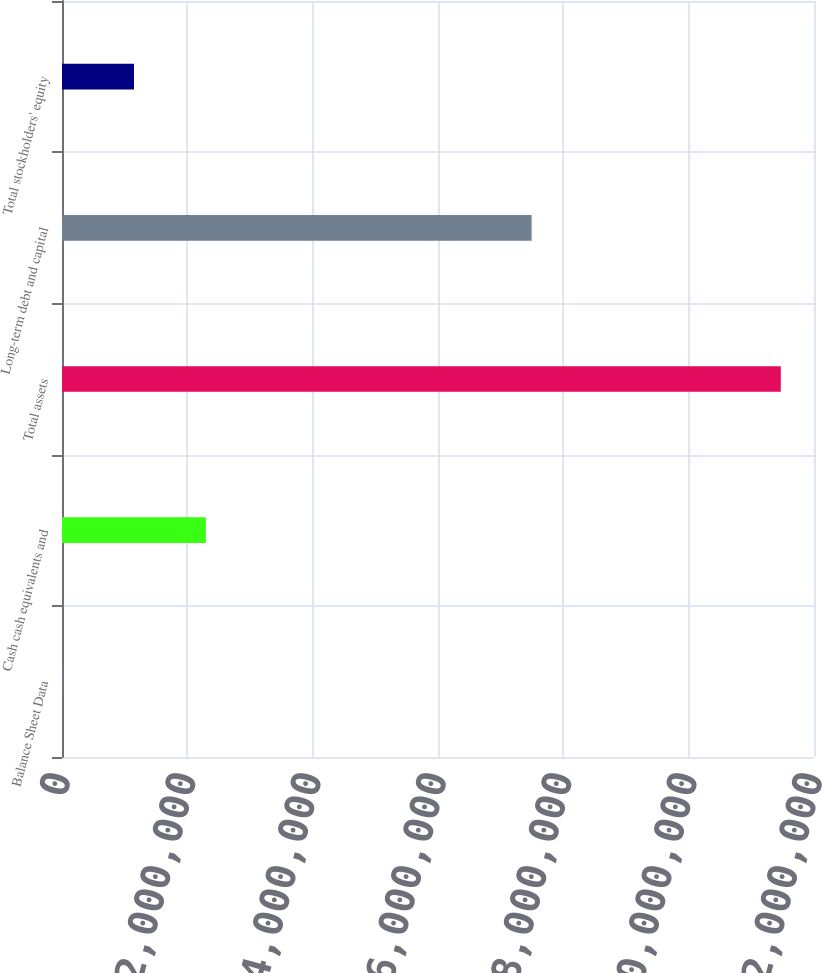<chart> <loc_0><loc_0><loc_500><loc_500><bar_chart><fcel>Balance Sheet Data<fcel>Cash cash equivalents and<fcel>Total assets<fcel>Long-term debt and capital<fcel>Total stockholders' equity<nl><fcel>2011<fcel>2.29566e+06<fcel>1.14702e+07<fcel>7.49378e+06<fcel>1.14883e+06<nl></chart> 